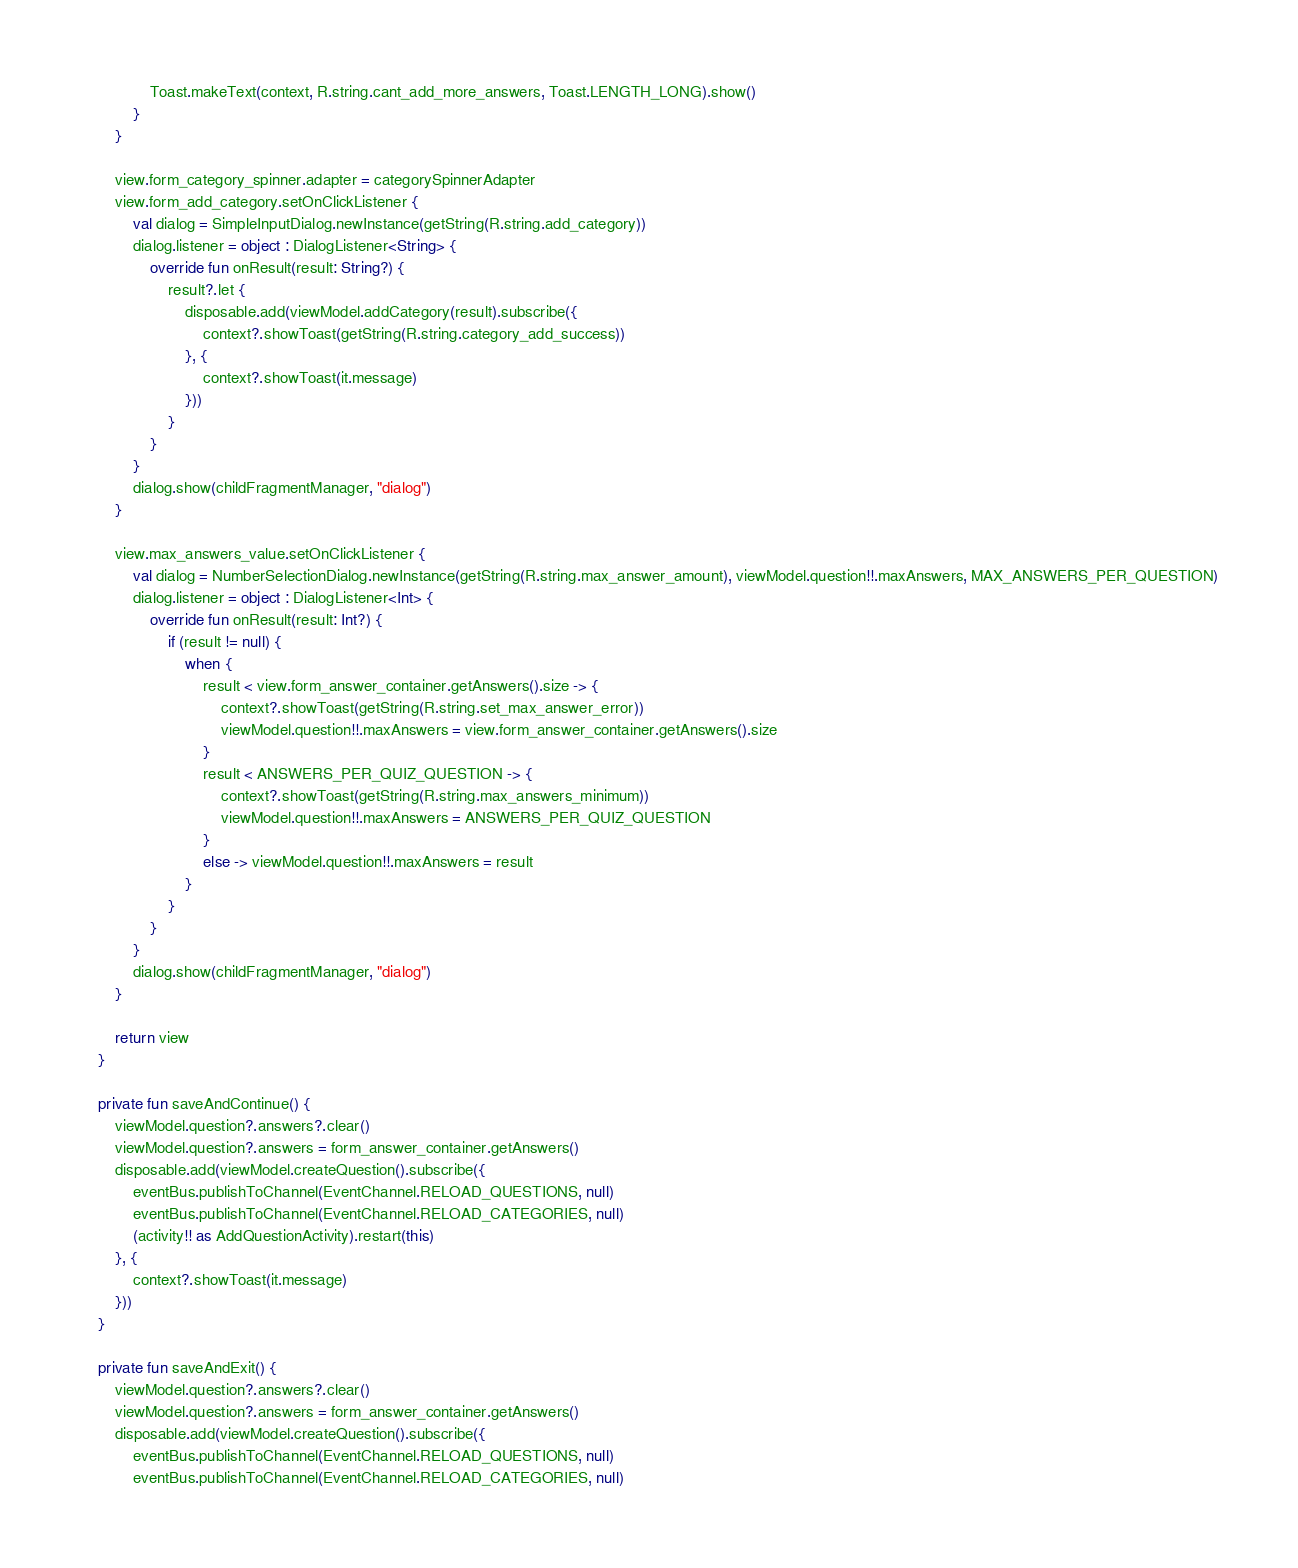Convert code to text. <code><loc_0><loc_0><loc_500><loc_500><_Kotlin_>                Toast.makeText(context, R.string.cant_add_more_answers, Toast.LENGTH_LONG).show()
            }
        }

        view.form_category_spinner.adapter = categorySpinnerAdapter
        view.form_add_category.setOnClickListener {
            val dialog = SimpleInputDialog.newInstance(getString(R.string.add_category))
            dialog.listener = object : DialogListener<String> {
                override fun onResult(result: String?) {
                    result?.let {
                        disposable.add(viewModel.addCategory(result).subscribe({
                            context?.showToast(getString(R.string.category_add_success))
                        }, {
                            context?.showToast(it.message)
                        }))
                    }
                }
            }
            dialog.show(childFragmentManager, "dialog")
        }

        view.max_answers_value.setOnClickListener {
            val dialog = NumberSelectionDialog.newInstance(getString(R.string.max_answer_amount), viewModel.question!!.maxAnswers, MAX_ANSWERS_PER_QUESTION)
            dialog.listener = object : DialogListener<Int> {
                override fun onResult(result: Int?) {
                    if (result != null) {
                        when {
                            result < view.form_answer_container.getAnswers().size -> {
                                context?.showToast(getString(R.string.set_max_answer_error))
                                viewModel.question!!.maxAnswers = view.form_answer_container.getAnswers().size
                            }
                            result < ANSWERS_PER_QUIZ_QUESTION -> {
                                context?.showToast(getString(R.string.max_answers_minimum))
                                viewModel.question!!.maxAnswers = ANSWERS_PER_QUIZ_QUESTION
                            }
                            else -> viewModel.question!!.maxAnswers = result
                        }
                    }
                }
            }
            dialog.show(childFragmentManager, "dialog")
        }

        return view
    }

    private fun saveAndContinue() {
        viewModel.question?.answers?.clear()
        viewModel.question?.answers = form_answer_container.getAnswers()
        disposable.add(viewModel.createQuestion().subscribe({
            eventBus.publishToChannel(EventChannel.RELOAD_QUESTIONS, null)
            eventBus.publishToChannel(EventChannel.RELOAD_CATEGORIES, null)
            (activity!! as AddQuestionActivity).restart(this)
        }, {
            context?.showToast(it.message)
        }))
    }

    private fun saveAndExit() {
        viewModel.question?.answers?.clear()
        viewModel.question?.answers = form_answer_container.getAnswers()
        disposable.add(viewModel.createQuestion().subscribe({
            eventBus.publishToChannel(EventChannel.RELOAD_QUESTIONS, null)
            eventBus.publishToChannel(EventChannel.RELOAD_CATEGORIES, null)</code> 